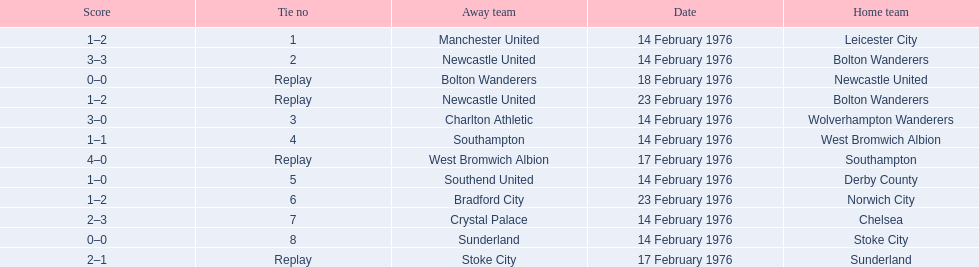What teams are featured in the game at the top of the table? Leicester City, Manchester United. Which of these two is the home team? Leicester City. 